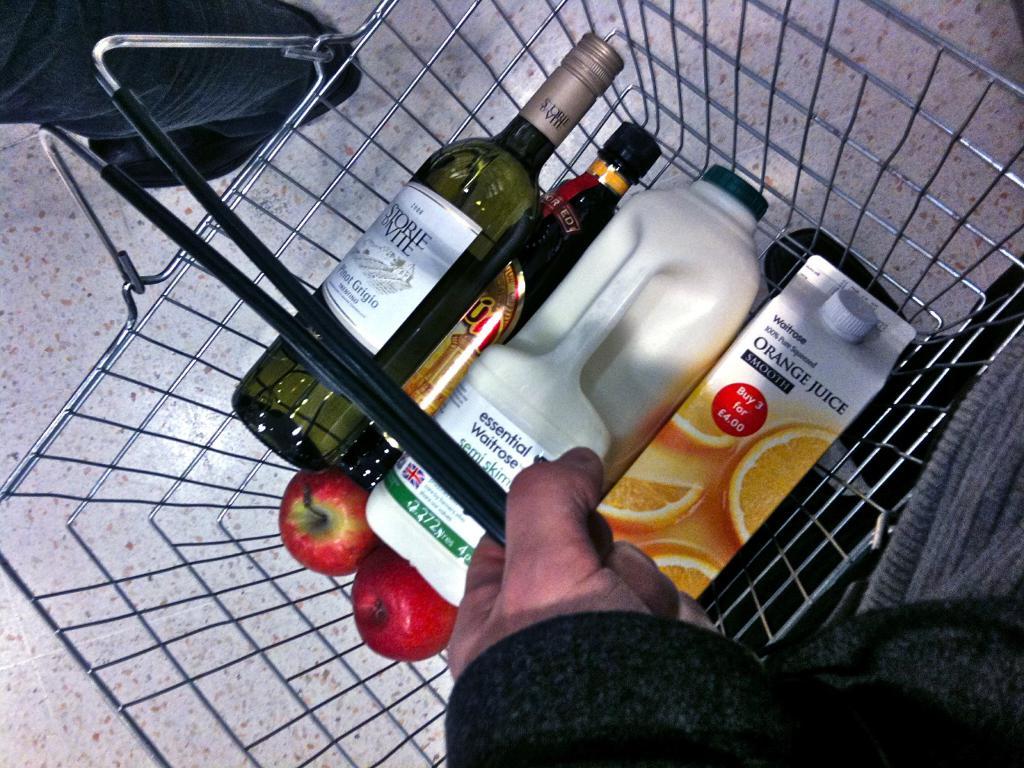What kind of juice is this person buying?
Your response must be concise. Orange. 